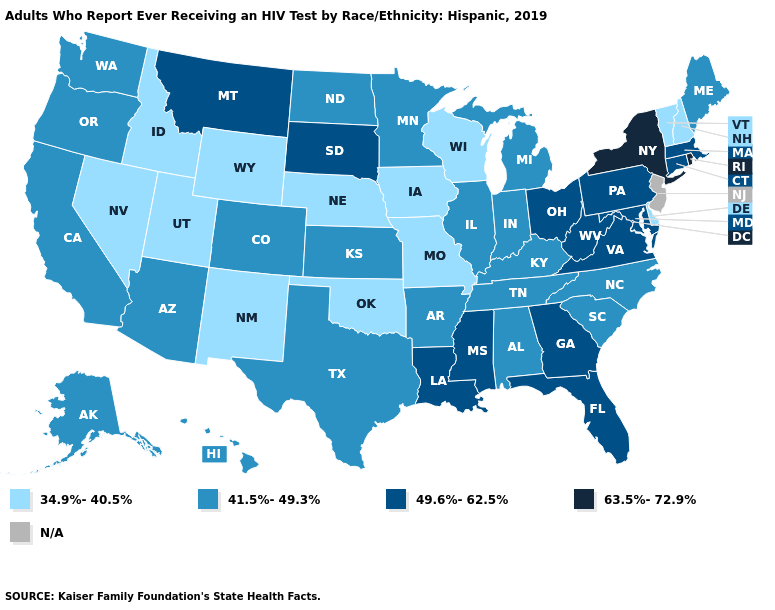Name the states that have a value in the range 49.6%-62.5%?
Short answer required. Connecticut, Florida, Georgia, Louisiana, Maryland, Massachusetts, Mississippi, Montana, Ohio, Pennsylvania, South Dakota, Virginia, West Virginia. Does the first symbol in the legend represent the smallest category?
Be succinct. Yes. Name the states that have a value in the range 41.5%-49.3%?
Answer briefly. Alabama, Alaska, Arizona, Arkansas, California, Colorado, Hawaii, Illinois, Indiana, Kansas, Kentucky, Maine, Michigan, Minnesota, North Carolina, North Dakota, Oregon, South Carolina, Tennessee, Texas, Washington. What is the value of North Dakota?
Short answer required. 41.5%-49.3%. Name the states that have a value in the range 49.6%-62.5%?
Write a very short answer. Connecticut, Florida, Georgia, Louisiana, Maryland, Massachusetts, Mississippi, Montana, Ohio, Pennsylvania, South Dakota, Virginia, West Virginia. Among the states that border Massachusetts , which have the lowest value?
Quick response, please. New Hampshire, Vermont. What is the value of Arkansas?
Quick response, please. 41.5%-49.3%. Among the states that border Maryland , does Pennsylvania have the lowest value?
Answer briefly. No. Among the states that border North Carolina , does Georgia have the highest value?
Quick response, please. Yes. Name the states that have a value in the range 49.6%-62.5%?
Quick response, please. Connecticut, Florida, Georgia, Louisiana, Maryland, Massachusetts, Mississippi, Montana, Ohio, Pennsylvania, South Dakota, Virginia, West Virginia. What is the value of Iowa?
Answer briefly. 34.9%-40.5%. What is the lowest value in states that border Connecticut?
Answer briefly. 49.6%-62.5%. Which states have the lowest value in the Northeast?
Concise answer only. New Hampshire, Vermont. 